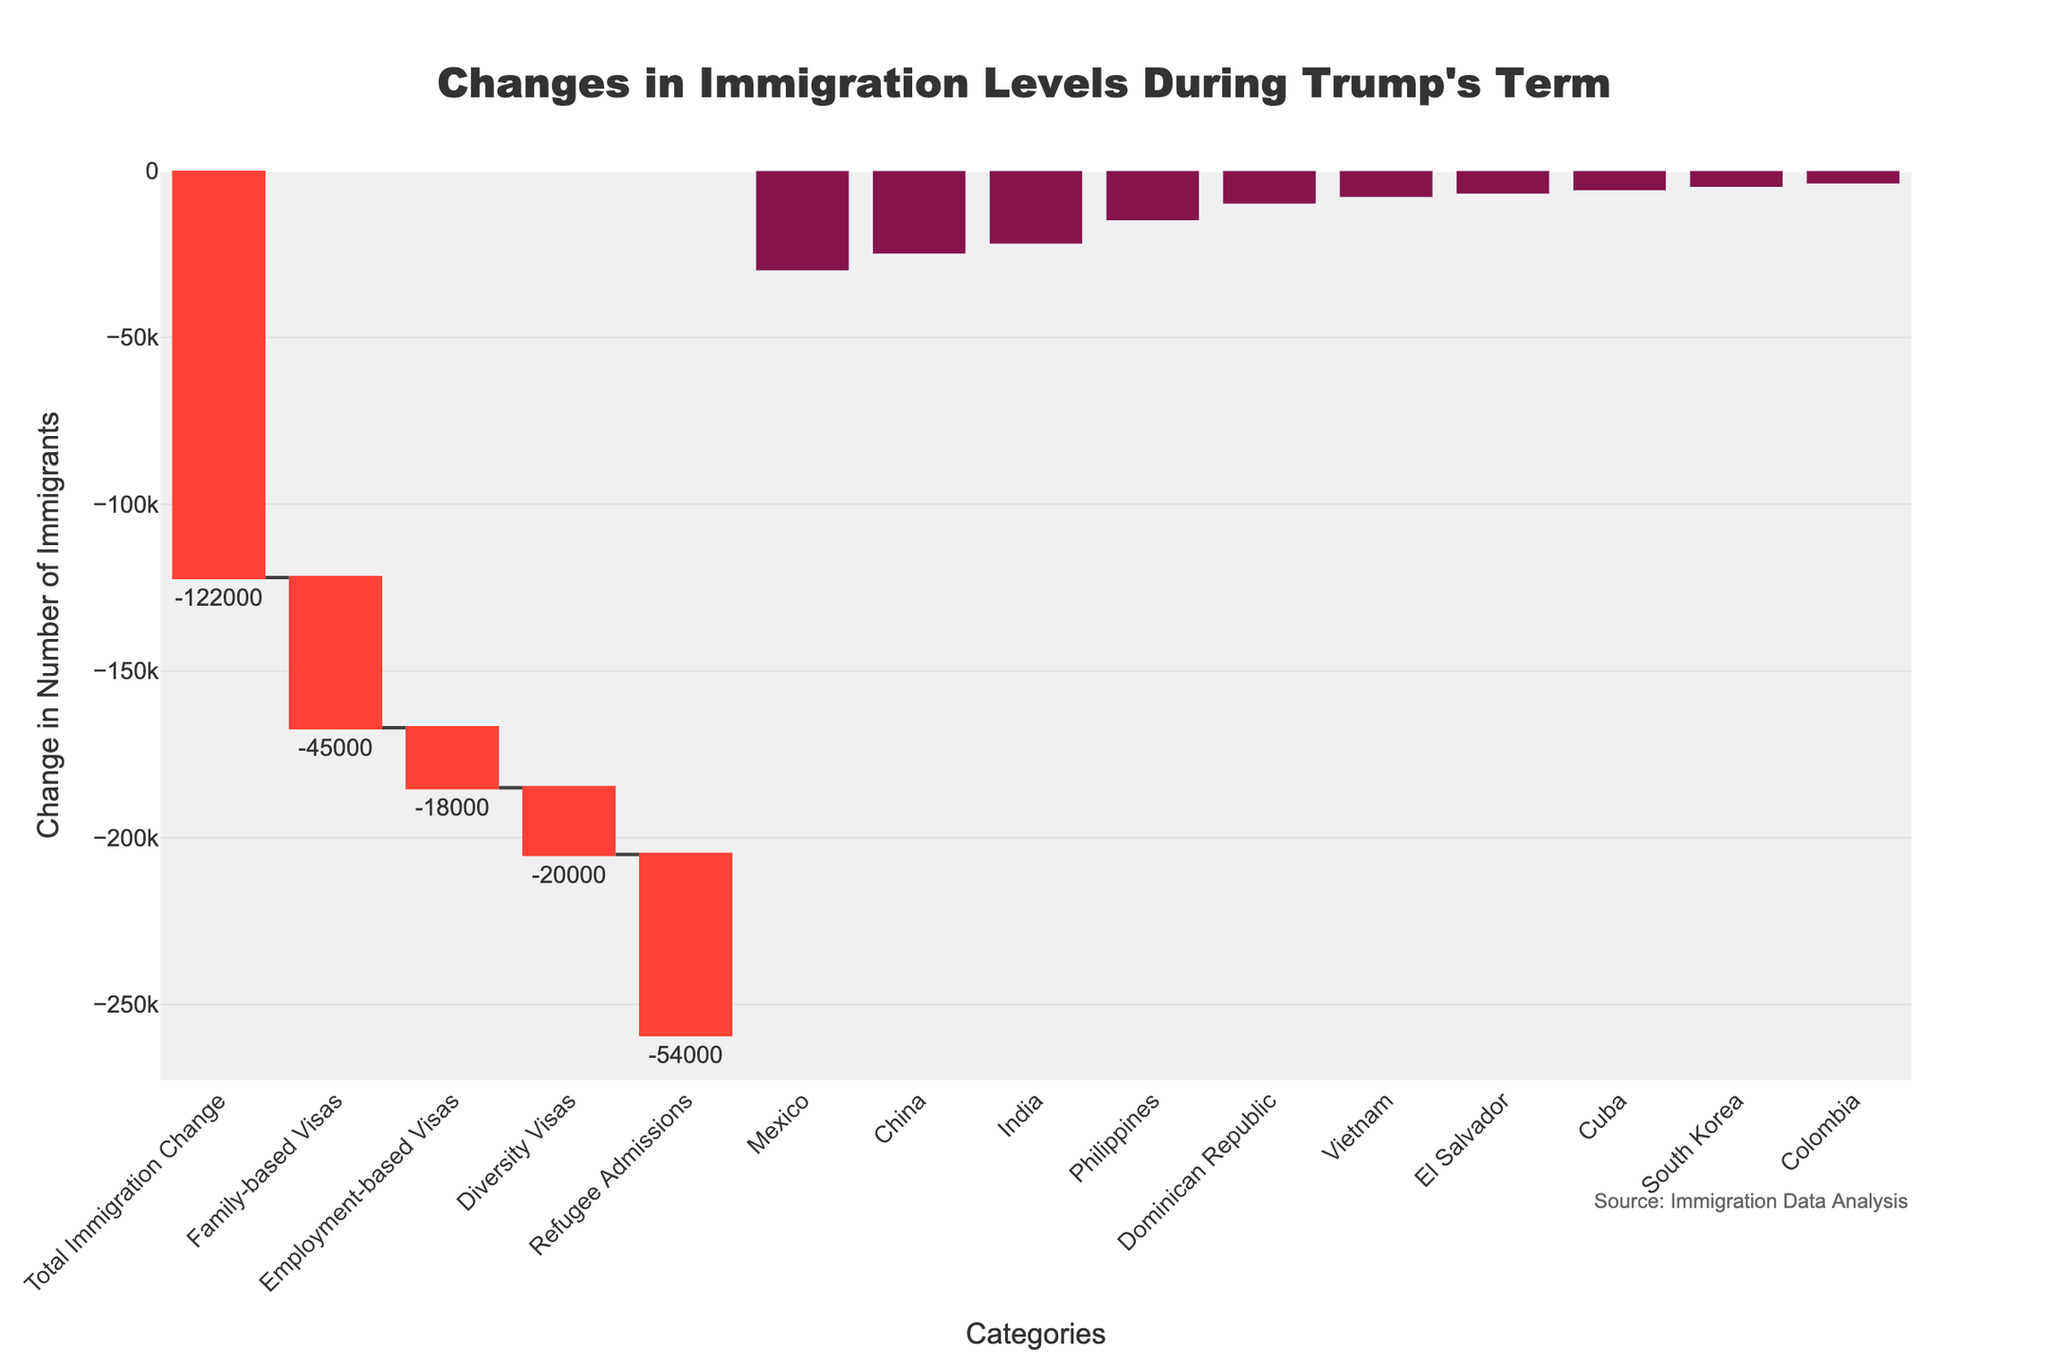What is the total change in immigration levels during Trump's term according to the chart? The total change is depicted at the top of the waterfall chart and is given as -122,000.
Answer: -122,000 Which visa type saw the largest decrease in immigrant numbers? By examining the first section of the chart where visa types are listed, the Refugee Admissions category shows the largest decrease with a change of -54,000.
Answer: Refugee Admissions How does the change in employment-based visas compare to family-based visas? The chart shows that family-based visas decreased by 45,000 and employment-based visas decreased by 18,000. Thus, family-based visas decreased by 27,000 more than employment-based visas.
Answer: Family-based visas decreased by 27,000 more than employment-based visas What is the combined decrease in the number of immigrants from Mexico, China, and India? Adding up the decreases from Mexico (-30,000), China (-25,000), and India (-22,000), the total combined decrease is 77,000.
Answer: 77,000 Which country experienced the smallest decrease in immigration levels? The chart shows that Colombia has the smallest decrease in immigration with a change of -4,000.
Answer: Colombia Of the visa types listed, which one saw the least decrease in numbers? The Employment-based visas show the least decrease of -18,000 among the visa types listed in the chart.
Answer: Employment-based visas What's the approximate average decrease in immigrant numbers for the countries listed? Summing up the decreases from all listed countries: -30,000 (Mexico) + -25,000 (China) + -22,000 (India) + -15,000 (Philippines) + -10,000 (Dominican Republic) + -8,000 (Vietnam) + -7,000 (El Salvador) + -6,000 (Cuba) + -5,000 (South Korea) + -4,000 (Colombia) = -132,000. Dividing by the 10 countries gives an average of approximately -13,200.
Answer: -13,200 What is the total immigration change attributed to visa types (excluding country-specific changes)? Adding up the changes specific to visa types: -45,000 (Family-based Visas) + -18,000 (Employment-based Visas) + -20,000 (Diversity Visas) + -54,000 (Refugee Admissions) = -137,000.
Answer: -137,000 How does the decrease in refugee admissions compare to the overall total change in immigration? Refugee admissions decreased by -54,000, while the total immigration change is -122,000. Refugee admissions account for nearly 44.26% of the total decrease (calculated as 54,000 / 122,000).
Answer: Approximately 44.26% 